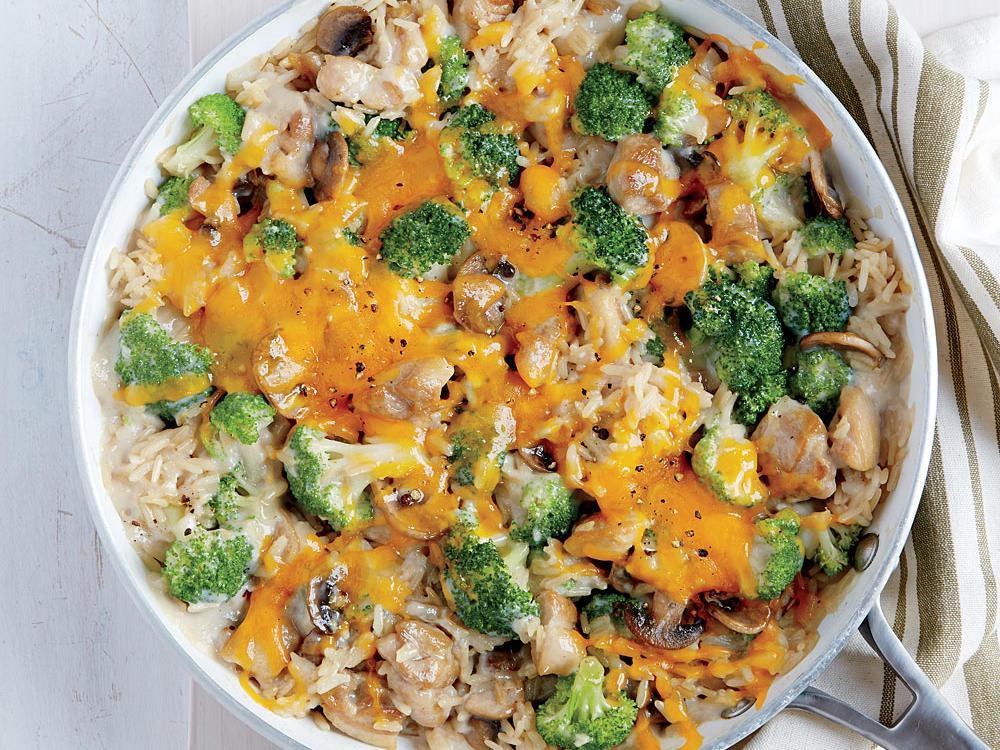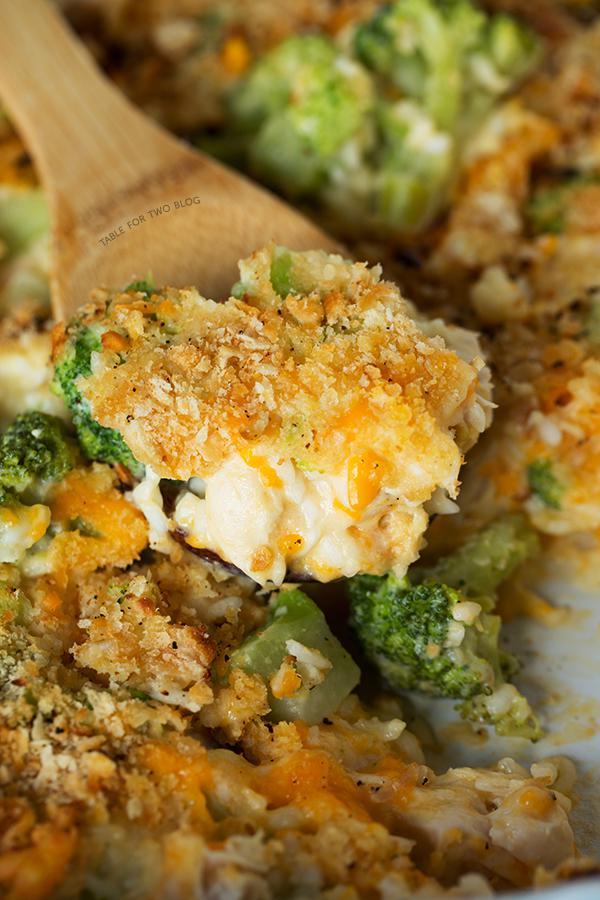The first image is the image on the left, the second image is the image on the right. Considering the images on both sides, is "In one image, the casserole is intact, and in the other image, part of it has been served and a wooden spoon can be seen." valid? Answer yes or no. Yes. The first image is the image on the left, the second image is the image on the right. Assess this claim about the two images: "A wooden spoon is stirring the food in the image on the right.". Correct or not? Answer yes or no. Yes. 